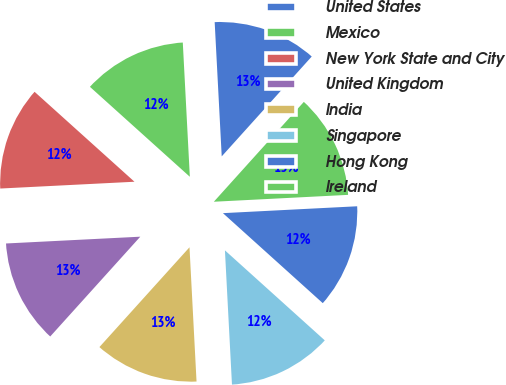Convert chart to OTSL. <chart><loc_0><loc_0><loc_500><loc_500><pie_chart><fcel>United States<fcel>Mexico<fcel>New York State and City<fcel>United Kingdom<fcel>India<fcel>Singapore<fcel>Hong Kong<fcel>Ireland<nl><fcel>12.51%<fcel>12.5%<fcel>12.47%<fcel>12.51%<fcel>12.52%<fcel>12.49%<fcel>12.49%<fcel>12.51%<nl></chart> 